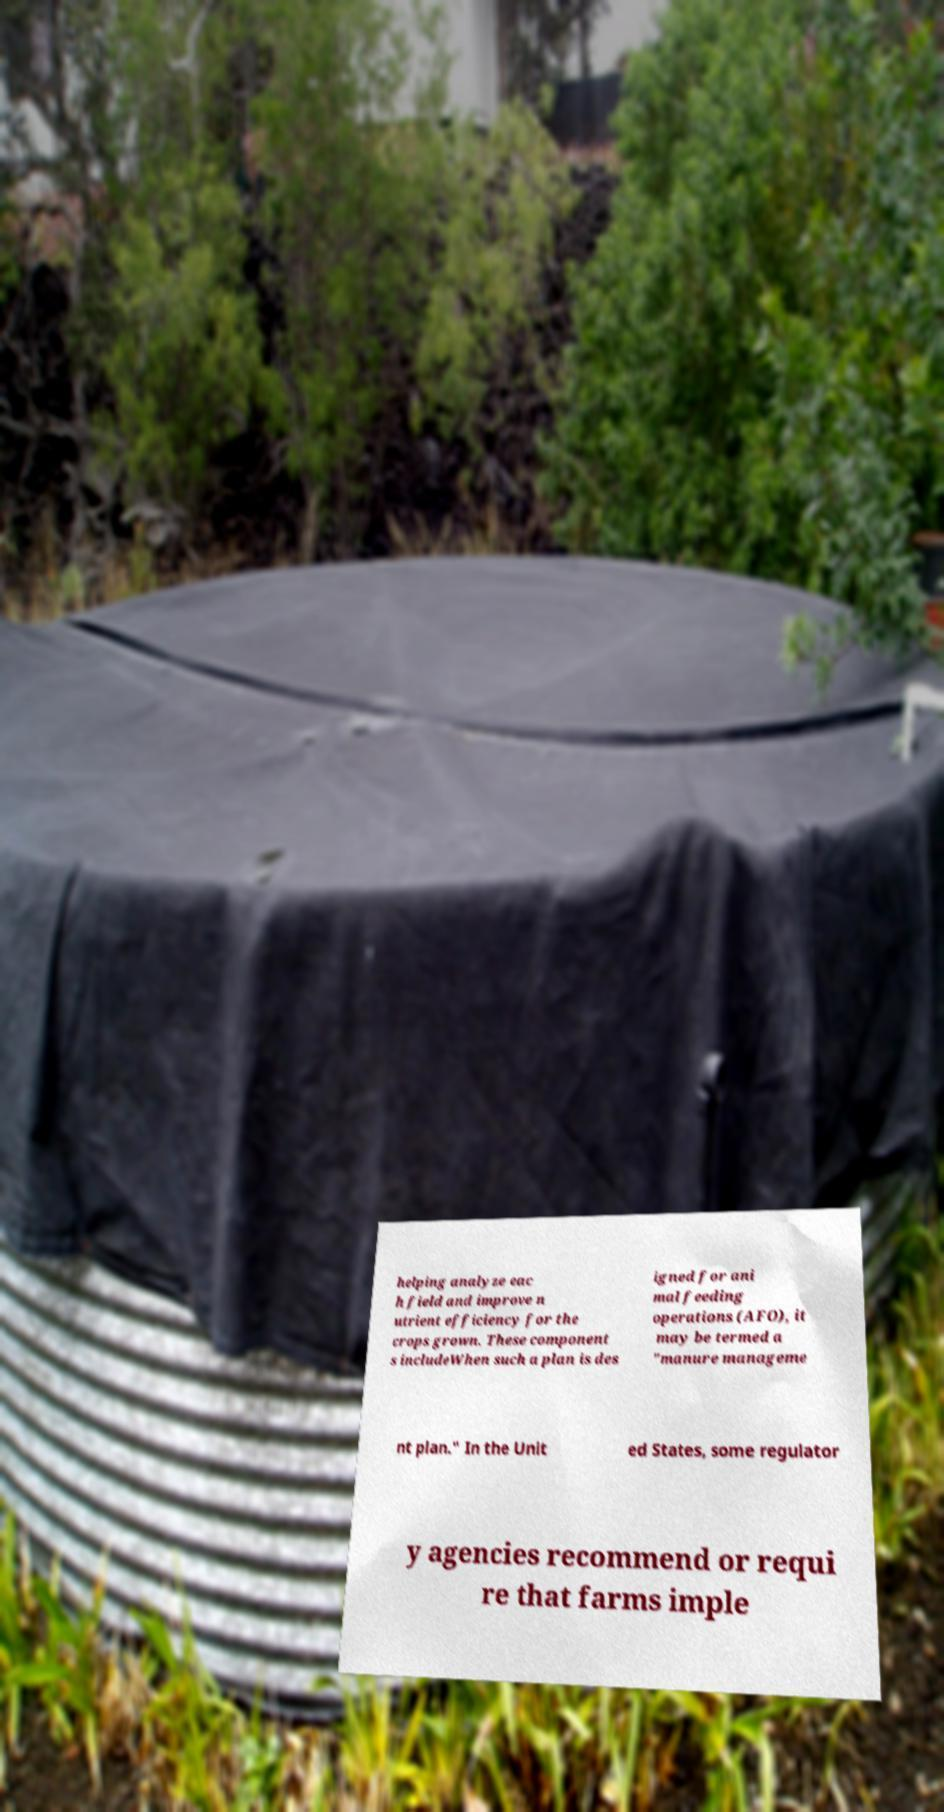For documentation purposes, I need the text within this image transcribed. Could you provide that? helping analyze eac h field and improve n utrient efficiency for the crops grown. These component s includeWhen such a plan is des igned for ani mal feeding operations (AFO), it may be termed a "manure manageme nt plan." In the Unit ed States, some regulator y agencies recommend or requi re that farms imple 